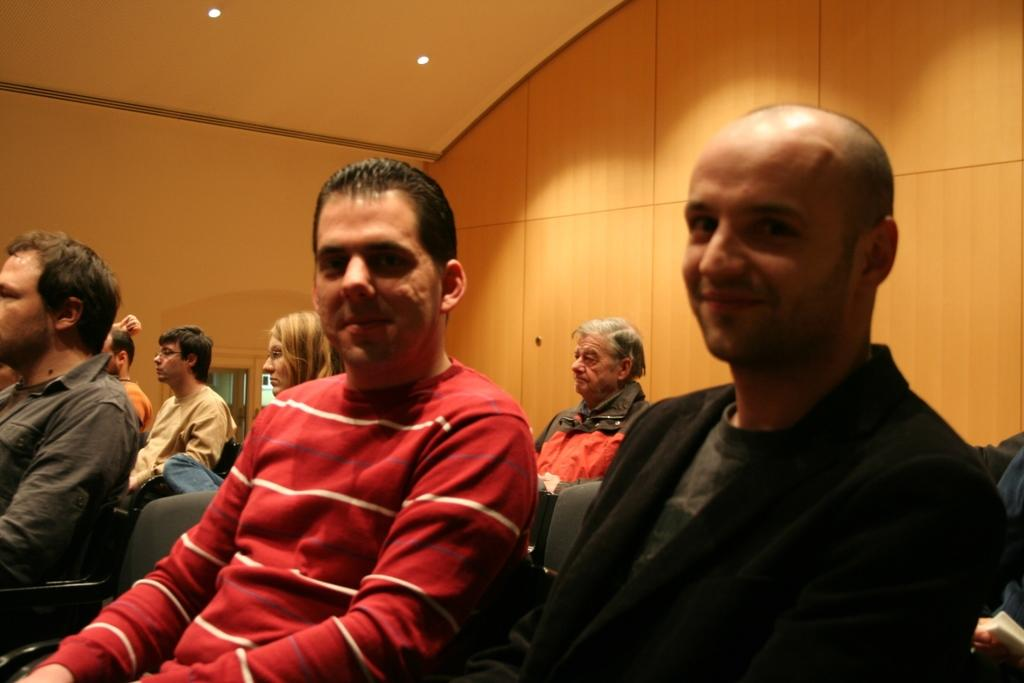How many people are in the image? There is a group of people in the image. What are the people doing in the image? The people are sitting on chairs. What can be seen behind the people in the image? There is a wall visible in the image. What architectural feature is present in the image? There is a door in the image. What is above the people in the image? There is a roof in the image. What type of lighting is present in the image? There are ceiling lights in the image. What type of fruit is being used to take a picture of the people in the image? There is no fruit, such as a quince, present in the image, nor is there any indication that a camera is being used to take a picture of the people. 